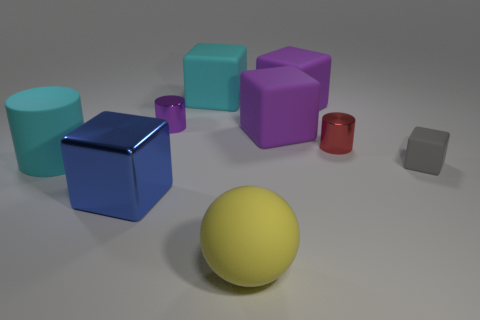There is another metal thing that is the same size as the yellow object; what is its shape?
Your response must be concise. Cube. Are there fewer gray blocks than metal things?
Offer a very short reply. Yes. There is a gray block that is behind the big yellow thing; is there a cyan thing in front of it?
Your response must be concise. No. The small object that is the same material as the ball is what shape?
Your response must be concise. Cube. Is there anything else that has the same color as the big sphere?
Make the answer very short. No. There is another tiny thing that is the same shape as the small purple metal object; what is its material?
Your answer should be compact. Metal. What number of other things are the same size as the cyan cylinder?
Make the answer very short. 5. What is the size of the cube that is the same color as the large cylinder?
Make the answer very short. Large. There is a cyan matte thing to the right of the large metal cube; is it the same shape as the red shiny thing?
Offer a terse response. No. What number of other objects are there of the same shape as the blue object?
Make the answer very short. 4. 